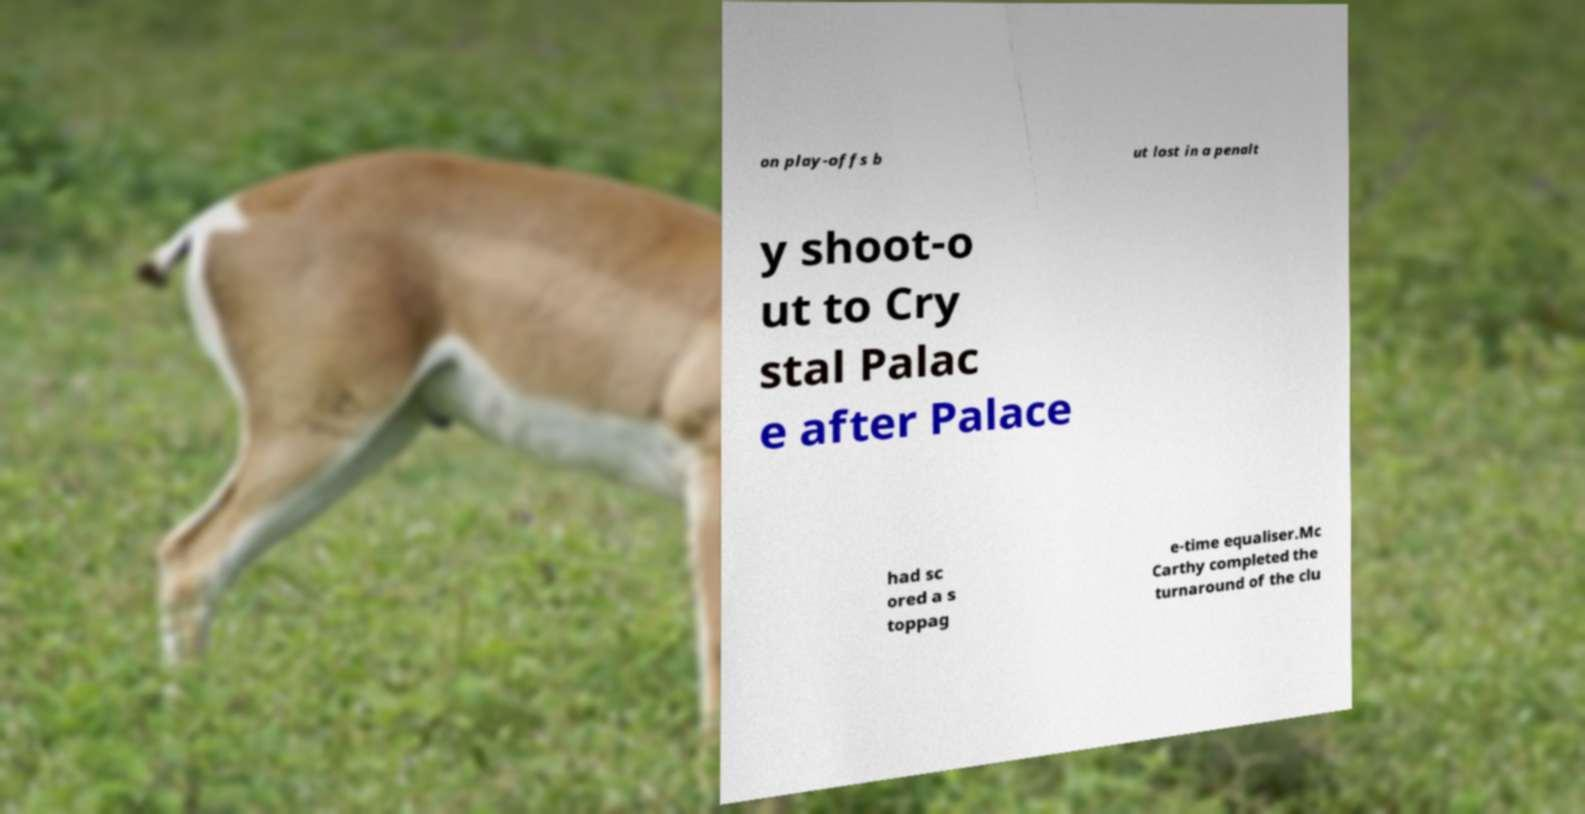Please read and relay the text visible in this image. What does it say? on play-offs b ut lost in a penalt y shoot-o ut to Cry stal Palac e after Palace had sc ored a s toppag e-time equaliser.Mc Carthy completed the turnaround of the clu 